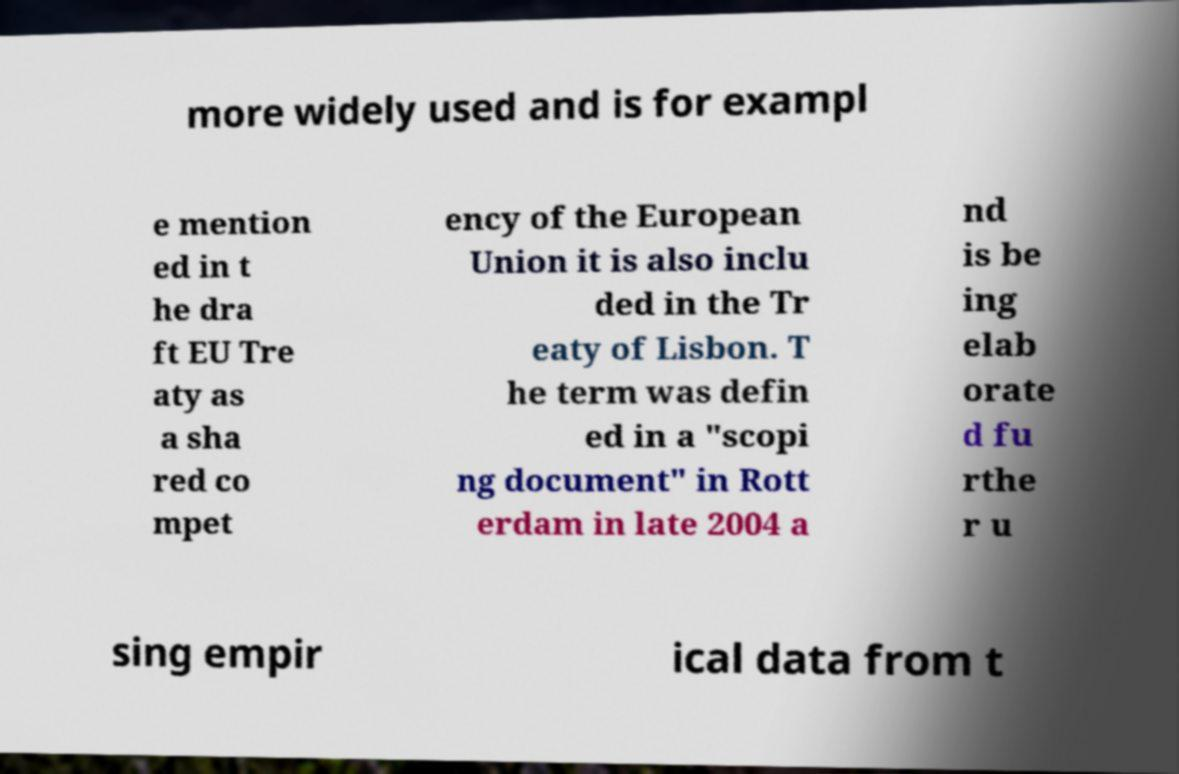I need the written content from this picture converted into text. Can you do that? more widely used and is for exampl e mention ed in t he dra ft EU Tre aty as a sha red co mpet ency of the European Union it is also inclu ded in the Tr eaty of Lisbon. T he term was defin ed in a "scopi ng document" in Rott erdam in late 2004 a nd is be ing elab orate d fu rthe r u sing empir ical data from t 